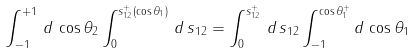Convert formula to latex. <formula><loc_0><loc_0><loc_500><loc_500>\int _ { - 1 } ^ { + 1 } \, d \, \cos \theta _ { 2 } \int _ { 0 } ^ { s _ { 1 2 } ^ { + } ( \cos \theta _ { 1 } ) } \, d \, s _ { 1 2 } = \int _ { 0 } ^ { s _ { 1 2 } ^ { + } } \, d \, s _ { 1 2 } \int _ { - 1 } ^ { \cos \theta _ { 1 } ^ { + } } d \, \cos \theta _ { 1 }</formula> 